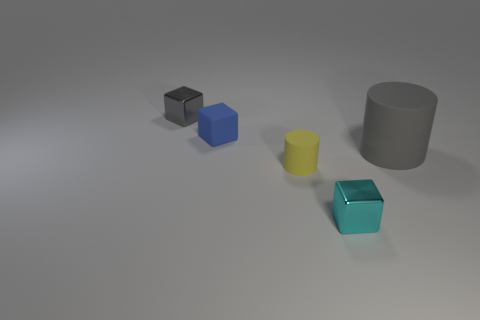Add 1 matte spheres. How many objects exist? 6 Subtract all metallic blocks. How many blocks are left? 1 Subtract all cylinders. How many objects are left? 3 Subtract 1 blocks. How many blocks are left? 2 Subtract all cyan blocks. Subtract all yellow spheres. How many blocks are left? 2 Subtract all green cylinders. How many red blocks are left? 0 Subtract all blue matte things. Subtract all gray things. How many objects are left? 2 Add 5 yellow objects. How many yellow objects are left? 6 Add 1 big yellow rubber cubes. How many big yellow rubber cubes exist? 1 Subtract all cyan blocks. How many blocks are left? 2 